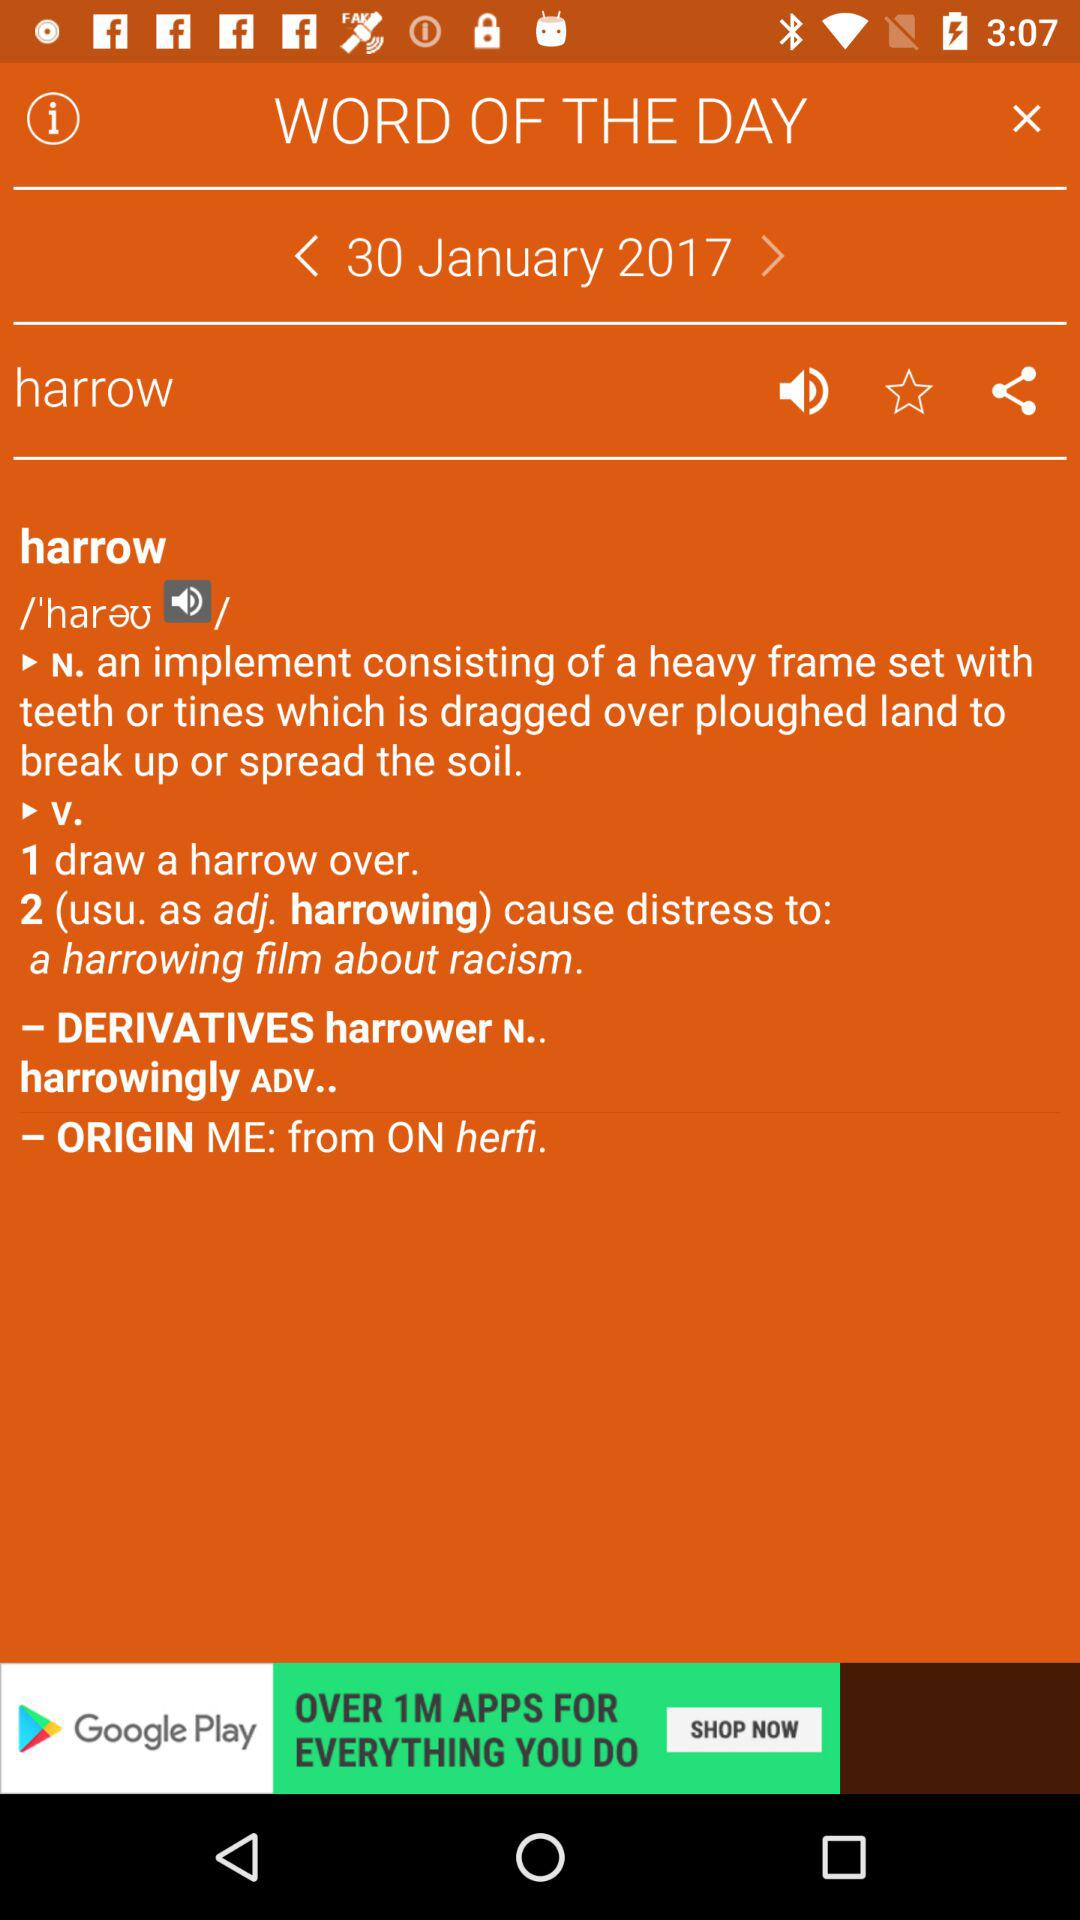What is the given date? The given date is January 30, 2017. 